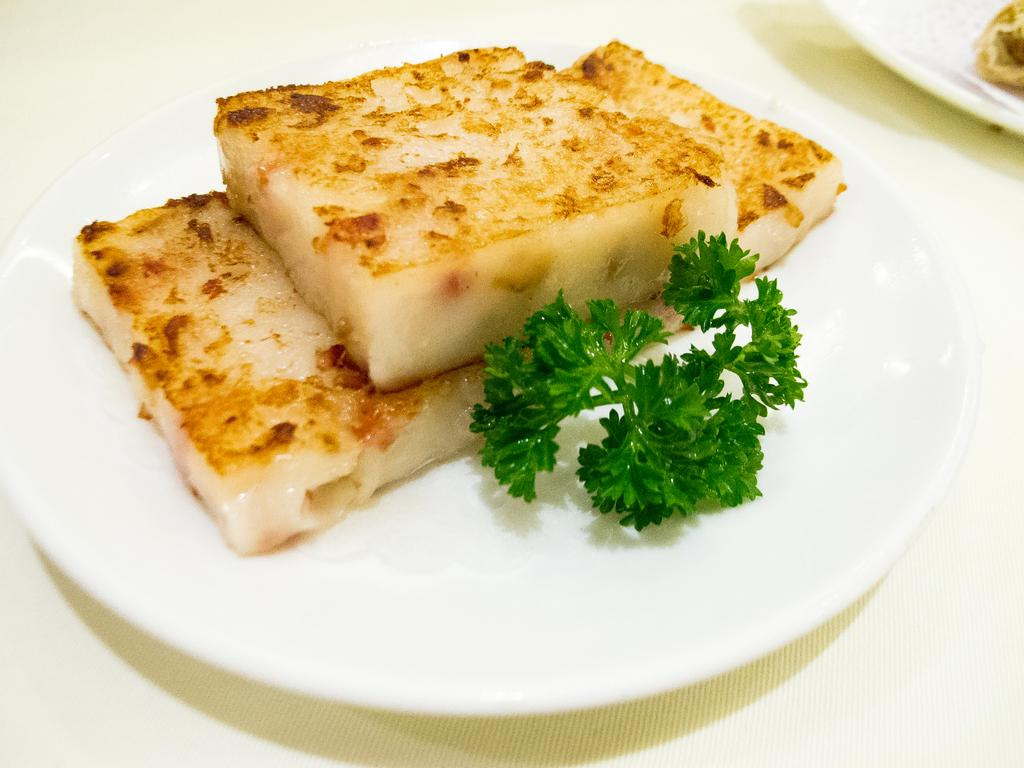What type of food can be seen in the image? The image contains food, but the specific type cannot be determined from the given facts. What colors are the food items in the image? The food is in brown and green colors. What color is the plate that holds the food? The plate is in white color. How many geese are attempting to eat the food in the image? There is no mention of geese or any attempt to eat the food in the image. 